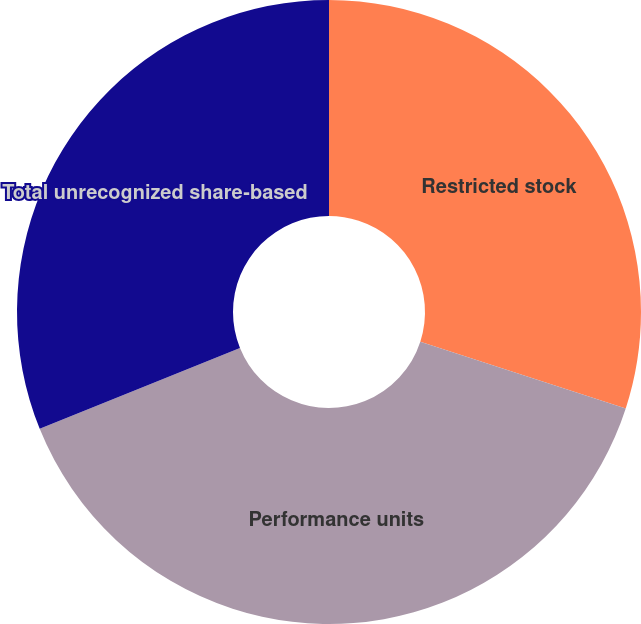Convert chart. <chart><loc_0><loc_0><loc_500><loc_500><pie_chart><fcel>Restricted stock<fcel>Performance units<fcel>Total unrecognized share-based<nl><fcel>30.0%<fcel>38.89%<fcel>31.11%<nl></chart> 